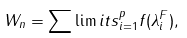Convert formula to latex. <formula><loc_0><loc_0><loc_500><loc_500>W _ { n } = \sum \lim i t s _ { i = 1 } ^ { p } f ( \lambda _ { i } ^ { F } ) ,</formula> 